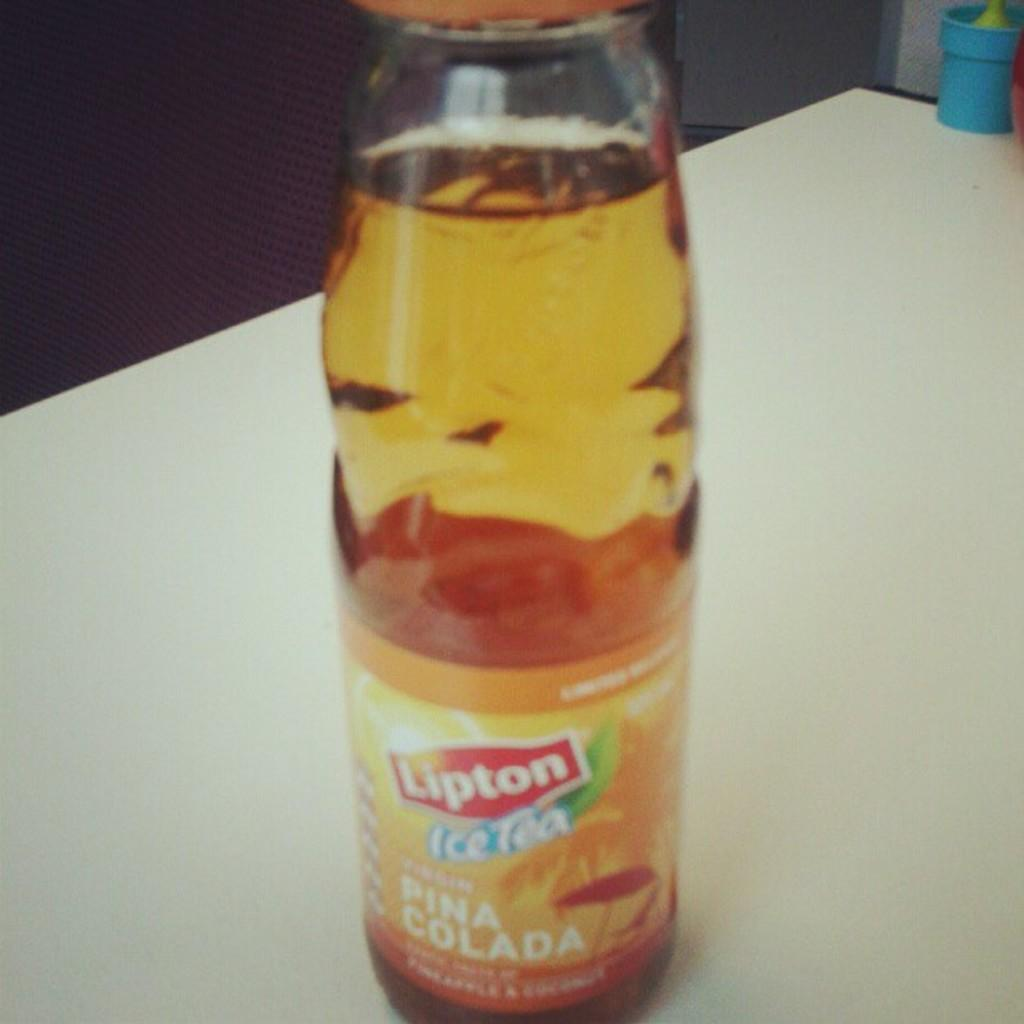What object is present in the image? There is a bottle in the image. What color is the bottle? The bottle is orange in color. Where is the bottle located? The bottle is on a white table. What is written on the bottle? "Lipton Ice Tea" is written on the bottle. Are there any snails crawling on the throne in the image? There is no throne present in the image, and therefore no snails can be observed on it. 